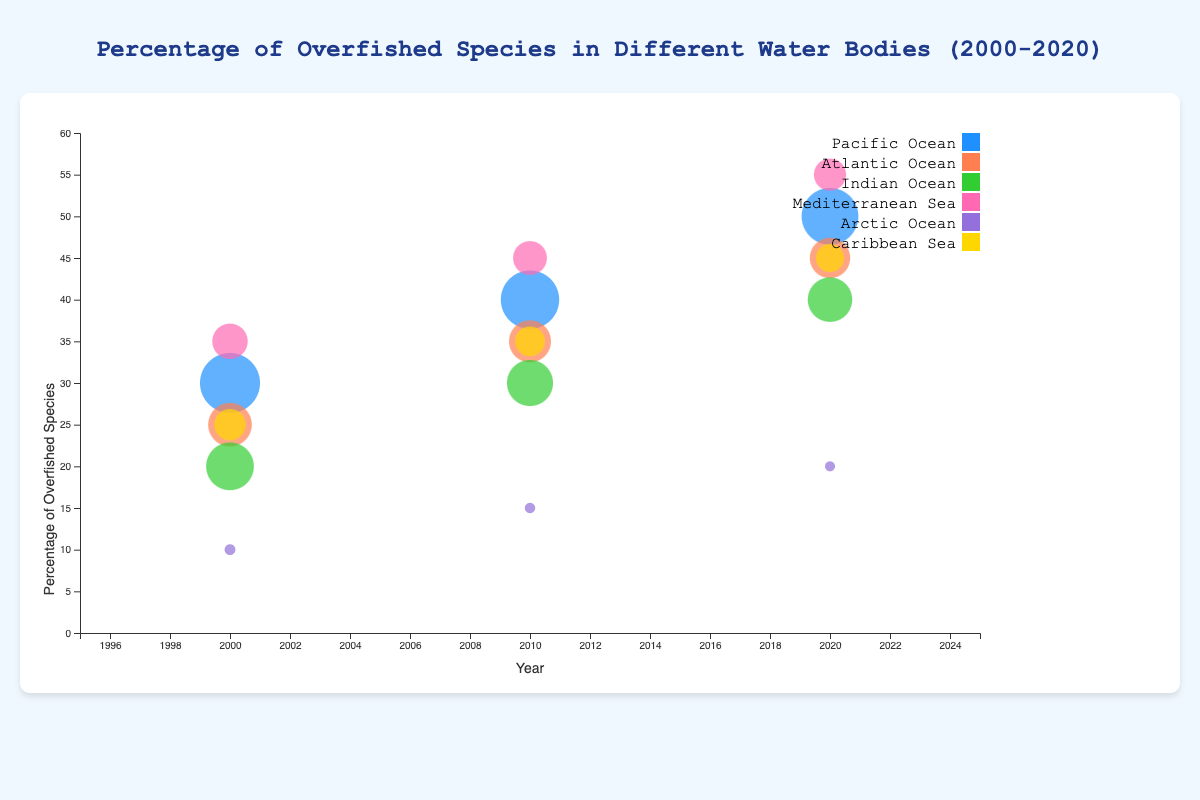What is the title of the chart? The title is written at the top of the chart, it reads "Percentage of Overfished Species in Different Water Bodies (2000-2020)"
Answer: Percentage of Overfished Species in Different Water Bodies (2000-2020) What do the sizes of the bubbles represent? According to the legend, the size of the bubbles represents the number of species in each year for each water body.
Answer: Number of species Which water body has the highest percentage of overfished species in 2020? In the chart, the bubble for the Mediterranean Sea in 2020 is the highest on the y-axis, indicating the highest percentage.
Answer: Mediterranean Sea How does the percentage of overfished species in the Pacific Ocean change from 2000 to 2020? The bubbles for the Pacific Ocean increase in height along the y-axis from 30% in 2000 to 50% in 2020.
Answer: It increases Which water body has the smallest bubble in 2020? The smallest bubble in 2020 is for the Arctic Ocean. The size represents the number of species, so it has the fewest species.
Answer: Arctic Ocean What is the difference in the percentage of overfished species between the Pacific Ocean and the Atlantic Ocean in 2010? The y-coordinate for the Pacific Ocean in 2010 is 40%, while for the Atlantic Ocean, it is 35%. The difference is 40% - 35%.
Answer: 5% In which year did the Mediterranean Sea have the highest percentage of overfished species? The highest bubble on the y-axis for the Mediterranean Sea is in 2020 with 55%.
Answer: 2020 What is the trend in the percentage of overfished species in the Indian Ocean from 2000 to 2020? The bubbles for the Indian Ocean move upward over the years, from 20% in 2000 to 40% in 2020, indicating an increasing trend.
Answer: Increasing trend 